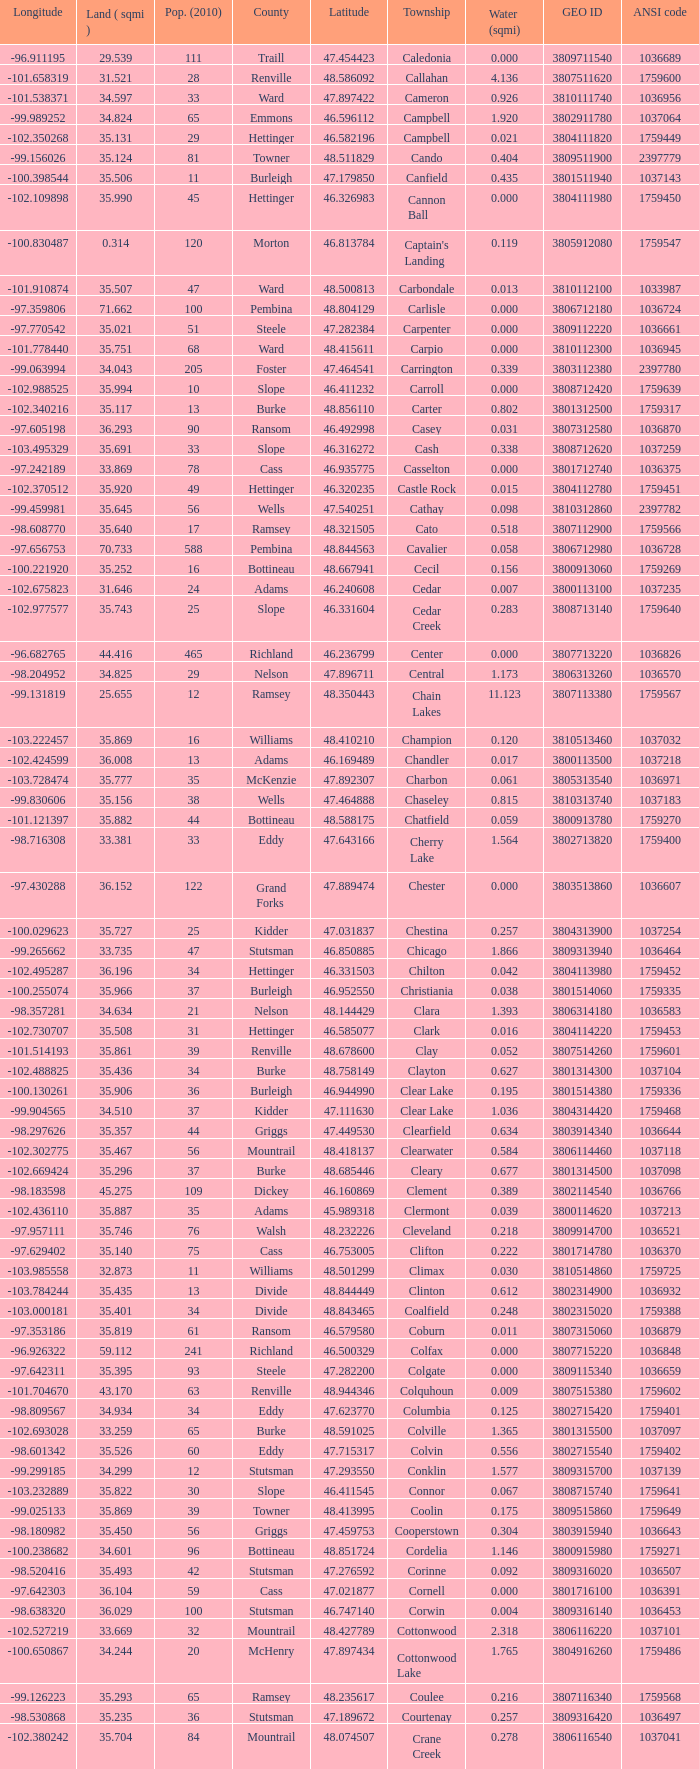What was the township with a geo ID of 3807116660? Creel. 